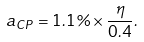Convert formula to latex. <formula><loc_0><loc_0><loc_500><loc_500>a _ { C P } = 1 . 1 \% \times \frac { \eta } { 0 . 4 } .</formula> 